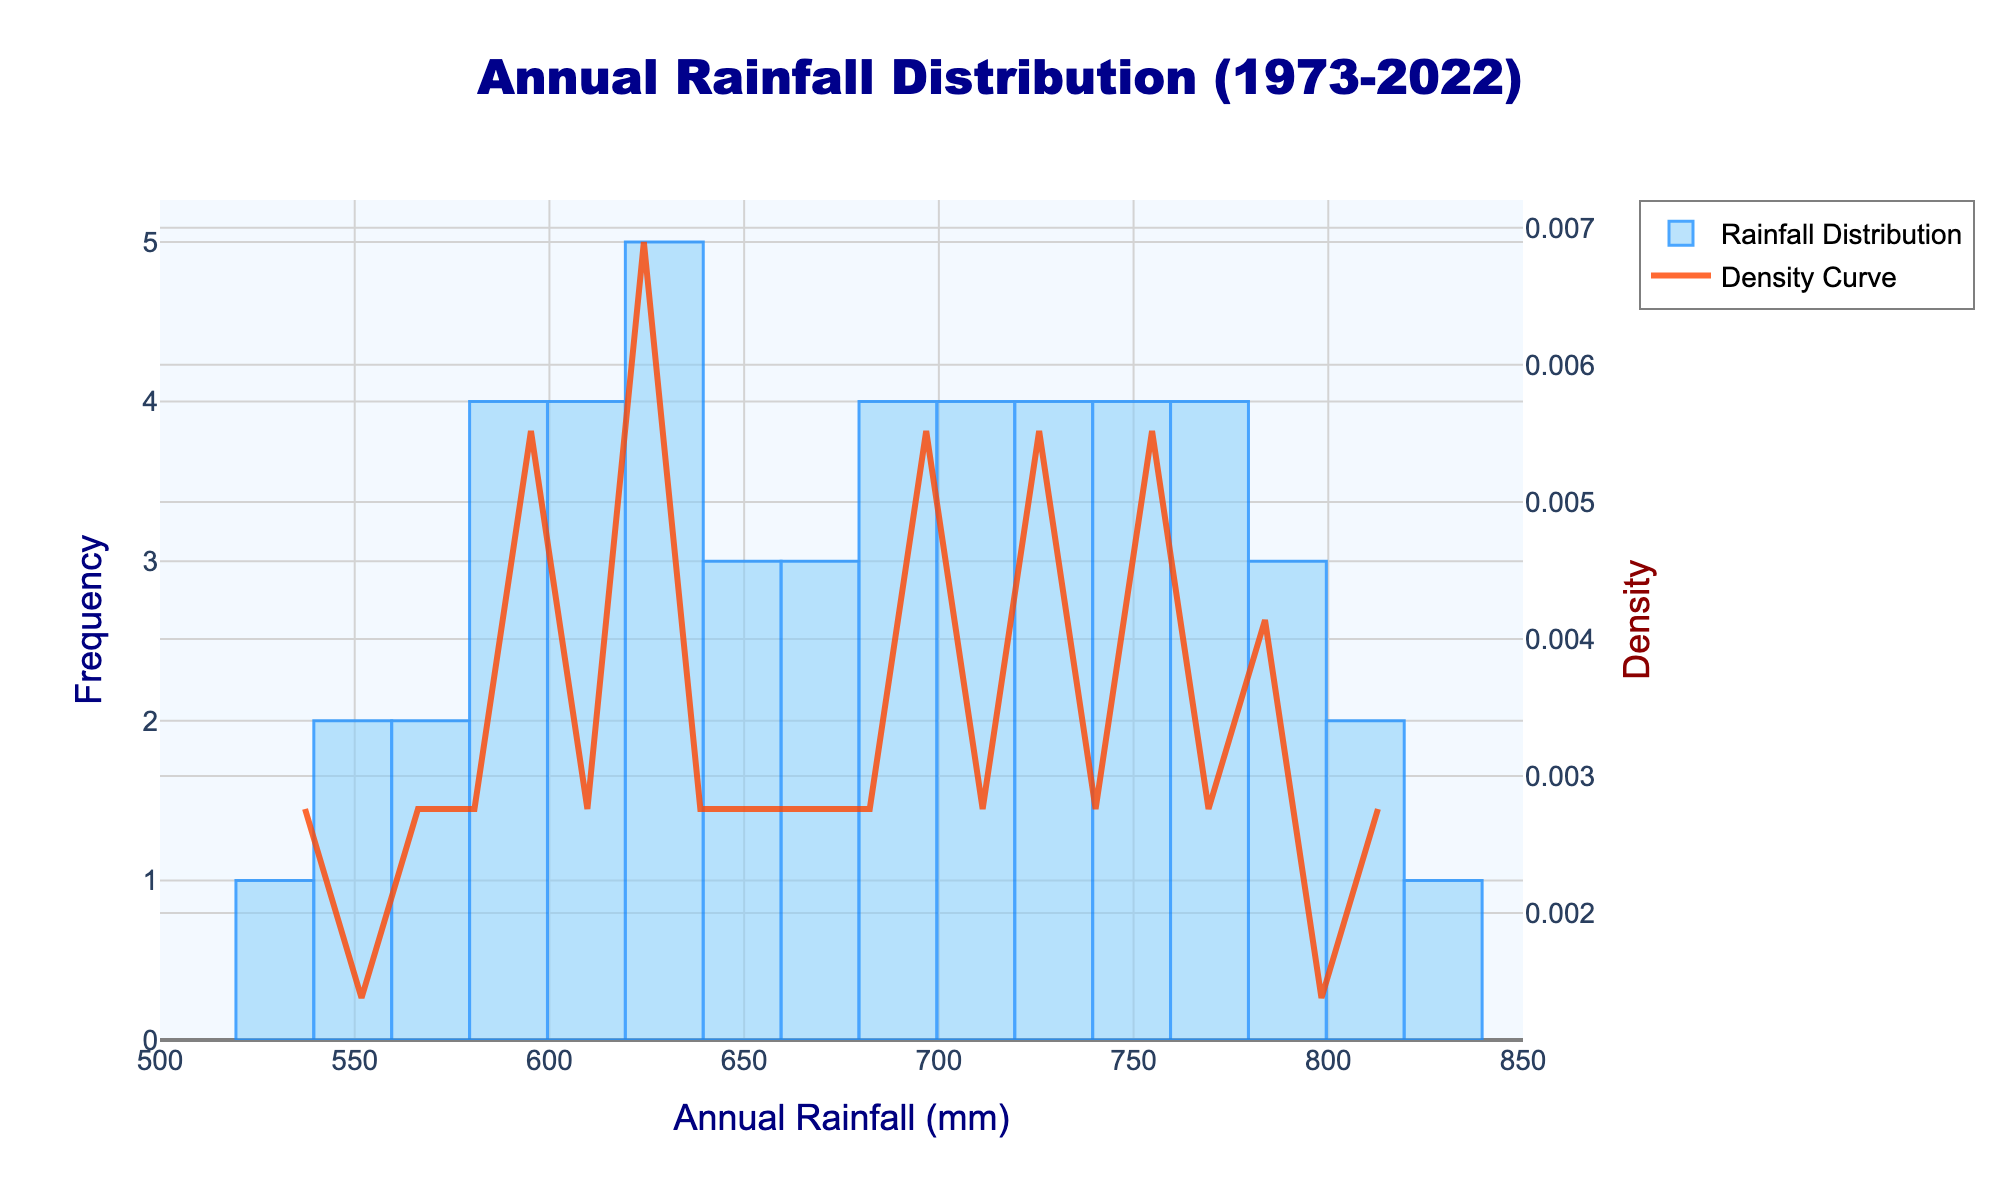What is the title of the histogram? The title is located at the top of the figure and is specified for the overall theme of the plot.
Answer: Annual Rainfall Distribution (1973-2022) What color is used for the bars of the histogram? The color for the bars in the histogram is visually identifiable.
Answer: Light blue What is the x-axis title of the histogram? The x-axis title is placed along the horizontal axis of the plot.
Answer: Annual Rainfall (mm) What is the y-axis title indicating the density? The y-axis on the right side is labeled to indicate the vertical data it represents.
Answer: Density Which annual rainfall range has the highest frequency according to the histogram? Identify the range along the x-axis where the histogram bars are tallest.
Answer: 730-740 mm What is the color of the density curve? The density curve is visually distinct and colored differently from the bars.
Answer: Orange What is the approximate range where the density curve peaks? Look at the density curve and determine the range along the x-axis where the peak is highest.
Answer: 730-740 mm How does the frequency of annual rainfall between 600 mm and 610 mm compare to the frequency between 810 mm and 820 mm? Compare the heights of the bars in the specified ranges on the histogram.
Answer: Lower for 600-610 mm than for 810-820 mm What is the overall trend observed in the density curve? Examine the shape of the density curve to identify any trends or patterns.
Answer: It increases to a peak around 730-740 mm and then decreases What is the frequency of annual rainfall around 700 mm? Look at the height of the bar near 700 mm on the histogram.
Answer: Moderate 